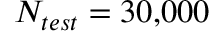<formula> <loc_0><loc_0><loc_500><loc_500>N _ { t e s t } = 3 0 , 0 0 0</formula> 